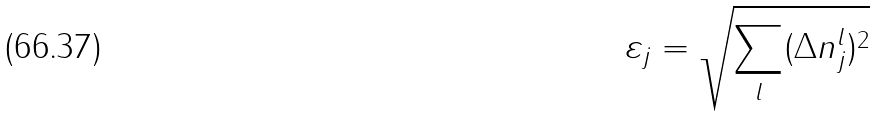Convert formula to latex. <formula><loc_0><loc_0><loc_500><loc_500>\varepsilon _ { j } = \sqrt { \sum _ { l } ( \Delta n _ { j } ^ { l } ) ^ { 2 } }</formula> 